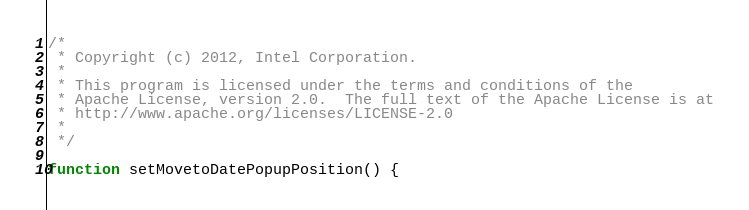Convert code to text. <code><loc_0><loc_0><loc_500><loc_500><_JavaScript_>/*
 * Copyright (c) 2012, Intel Corporation.
 *
 * This program is licensed under the terms and conditions of the
 * Apache License, version 2.0.  The full text of the Apache License is at
 * http://www.apache.org/licenses/LICENSE-2.0
 *
 */

function setMovetoDatePopupPosition() {</code> 